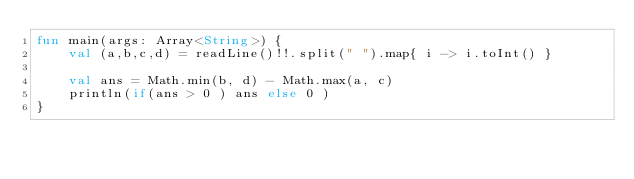<code> <loc_0><loc_0><loc_500><loc_500><_Kotlin_>fun main(args: Array<String>) {
    val (a,b,c,d) = readLine()!!.split(" ").map{ i -> i.toInt() }

    val ans = Math.min(b, d) - Math.max(a, c)
    println(if(ans > 0 ) ans else 0 )
}</code> 